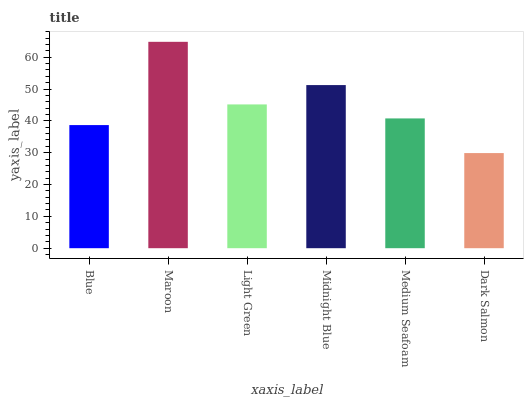Is Light Green the minimum?
Answer yes or no. No. Is Light Green the maximum?
Answer yes or no. No. Is Maroon greater than Light Green?
Answer yes or no. Yes. Is Light Green less than Maroon?
Answer yes or no. Yes. Is Light Green greater than Maroon?
Answer yes or no. No. Is Maroon less than Light Green?
Answer yes or no. No. Is Light Green the high median?
Answer yes or no. Yes. Is Medium Seafoam the low median?
Answer yes or no. Yes. Is Blue the high median?
Answer yes or no. No. Is Light Green the low median?
Answer yes or no. No. 